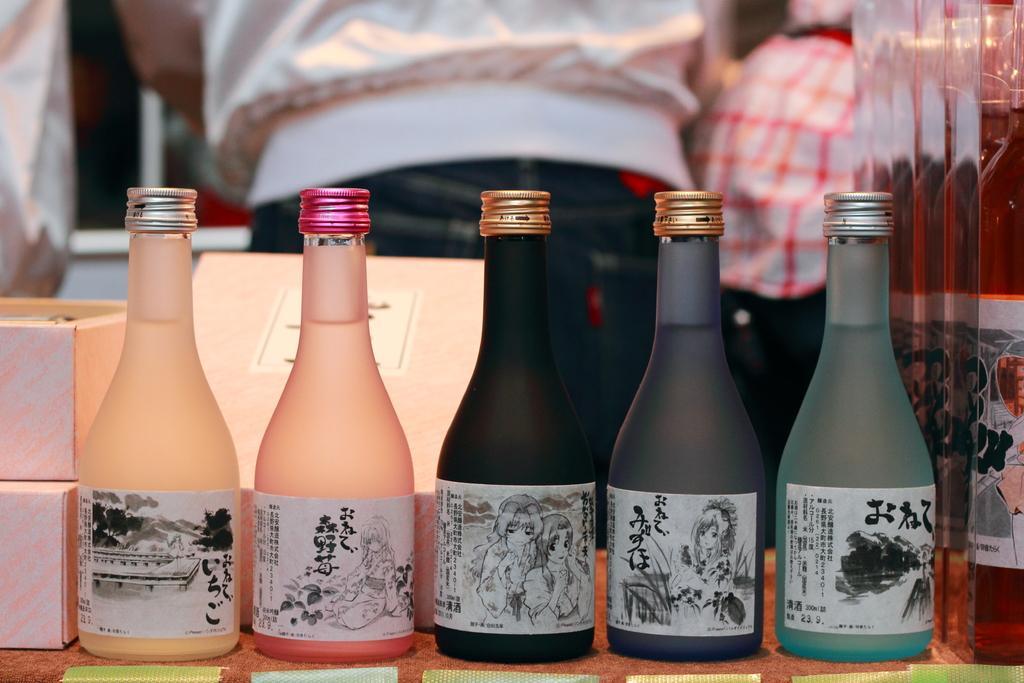In one or two sentences, can you explain what this image depicts? There are five bottles and these are the boxes. 